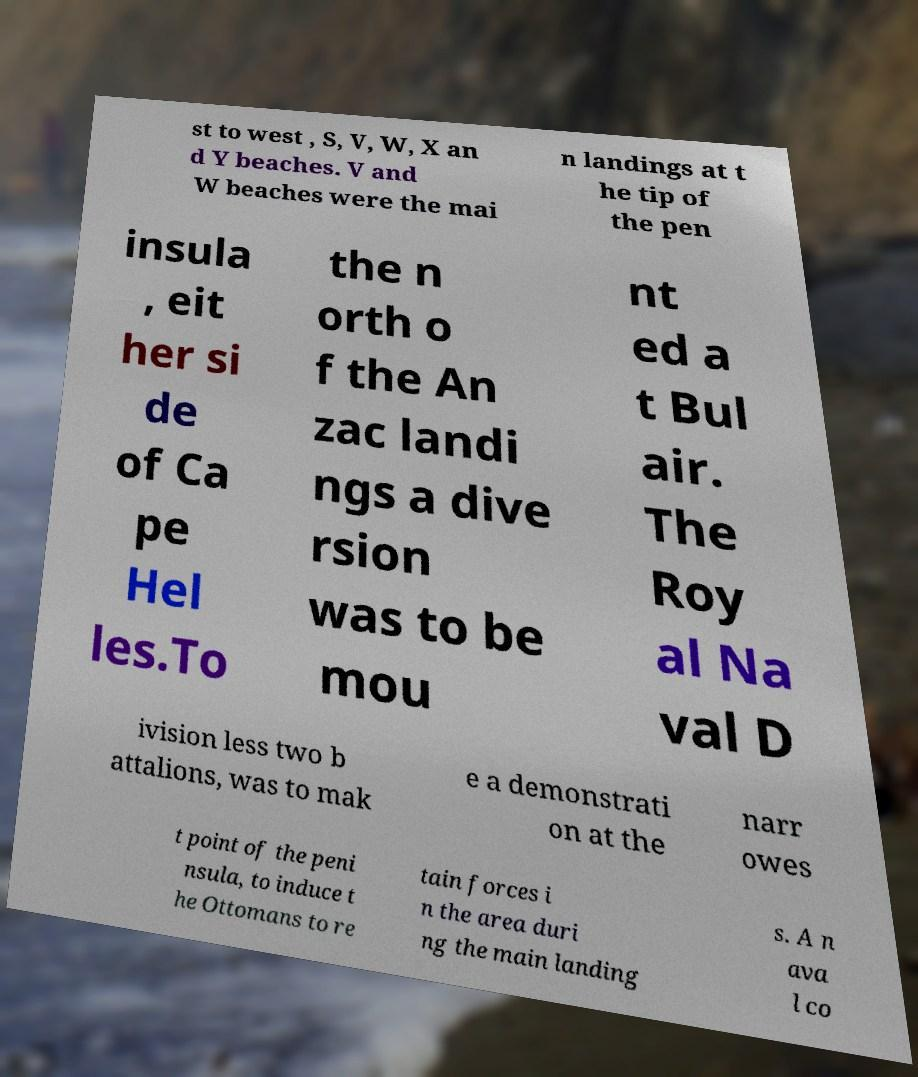There's text embedded in this image that I need extracted. Can you transcribe it verbatim? st to west , S, V, W, X an d Y beaches. V and W beaches were the mai n landings at t he tip of the pen insula , eit her si de of Ca pe Hel les.To the n orth o f the An zac landi ngs a dive rsion was to be mou nt ed a t Bul air. The Roy al Na val D ivision less two b attalions, was to mak e a demonstrati on at the narr owes t point of the peni nsula, to induce t he Ottomans to re tain forces i n the area duri ng the main landing s. A n ava l co 